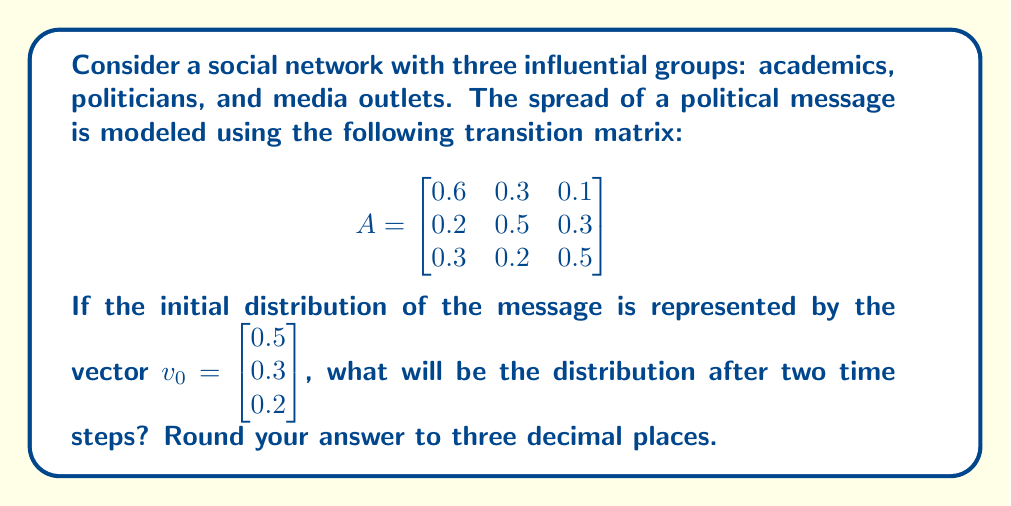Give your solution to this math problem. To solve this problem, we need to multiply the initial distribution vector by the transition matrix twice. Let's break it down step-by-step:

1) First, let's calculate the distribution after one time step:

   $v_1 = A \cdot v_0$

   $$\begin{bmatrix}
   0.6 & 0.3 & 0.1 \\
   0.2 & 0.5 & 0.3 \\
   0.3 & 0.2 & 0.5
   \end{bmatrix} \cdot \begin{bmatrix}
   0.5 \\
   0.3 \\
   0.2
   \end{bmatrix}$$

   $= \begin{bmatrix}
   (0.6 \cdot 0.5) + (0.3 \cdot 0.3) + (0.1 \cdot 0.2) \\
   (0.2 \cdot 0.5) + (0.5 \cdot 0.3) + (0.3 \cdot 0.2) \\
   (0.3 \cdot 0.5) + (0.2 \cdot 0.3) + (0.5 \cdot 0.2)
   \end{bmatrix}$

   $= \begin{bmatrix}
   0.3 + 0.09 + 0.02 \\
   0.1 + 0.15 + 0.06 \\
   0.15 + 0.06 + 0.1
   \end{bmatrix} = \begin{bmatrix}
   0.41 \\
   0.31 \\
   0.31
   \end{bmatrix}$

2) Now, we calculate the distribution after two time steps:

   $v_2 = A \cdot v_1$

   $$\begin{bmatrix}
   0.6 & 0.3 & 0.1 \\
   0.2 & 0.5 & 0.3 \\
   0.3 & 0.2 & 0.5
   \end{bmatrix} \cdot \begin{bmatrix}
   0.41 \\
   0.31 \\
   0.31
   \end{bmatrix}$$

   $= \begin{bmatrix}
   (0.6 \cdot 0.41) + (0.3 \cdot 0.31) + (0.1 \cdot 0.31) \\
   (0.2 \cdot 0.41) + (0.5 \cdot 0.31) + (0.3 \cdot 0.31) \\
   (0.3 \cdot 0.41) + (0.2 \cdot 0.31) + (0.5 \cdot 0.31)
   \end{bmatrix}$

   $= \begin{bmatrix}
   0.246 + 0.093 + 0.031 \\
   0.082 + 0.155 + 0.093 \\
   0.123 + 0.062 + 0.155
   \end{bmatrix} = \begin{bmatrix}
   0.370 \\
   0.330 \\
   0.340
   \end{bmatrix}$

3) Rounding to three decimal places, we get:

   $v_2 = \begin{bmatrix}
   0.370 \\
   0.330 \\
   0.340
   \end{bmatrix}$

This final vector represents the distribution of the political message among academics (0.370), politicians (0.330), and media outlets (0.340) after two time steps.
Answer: $\begin{bmatrix} 0.370 \\ 0.330 \\ 0.340 \end{bmatrix}$ 